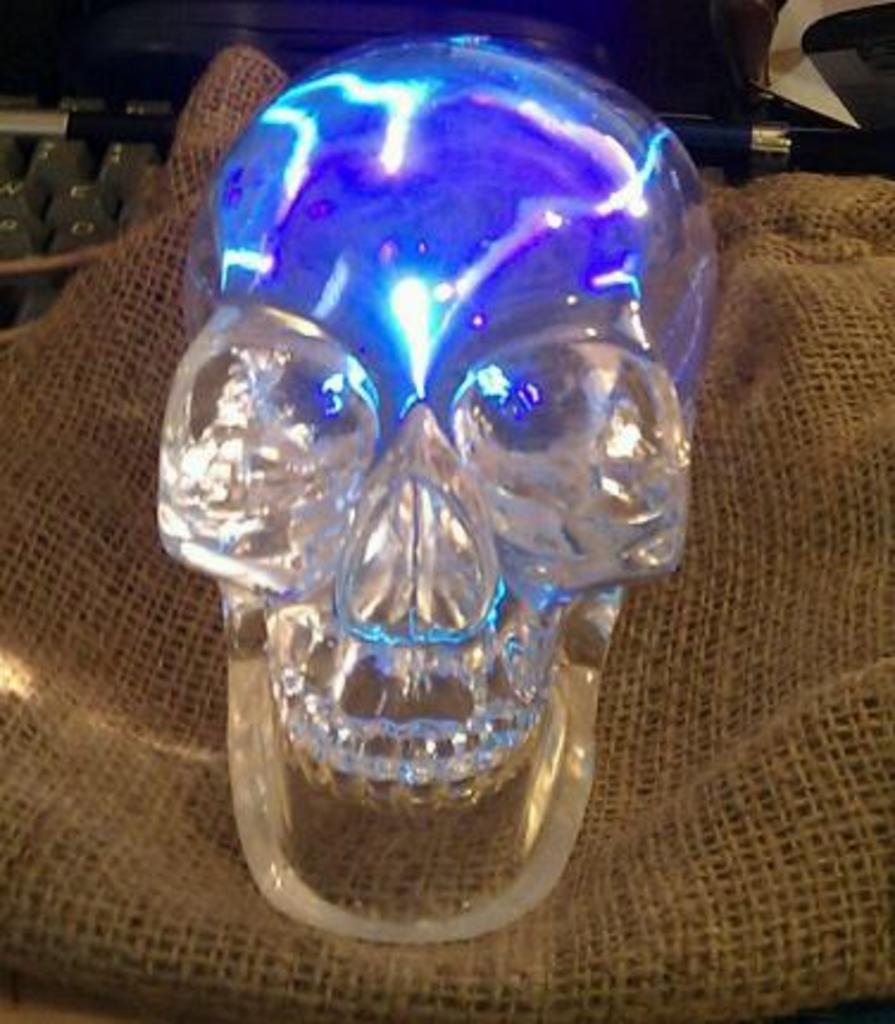Please provide a concise description of this image. As we can see in the image there is a skull and jute bag. 